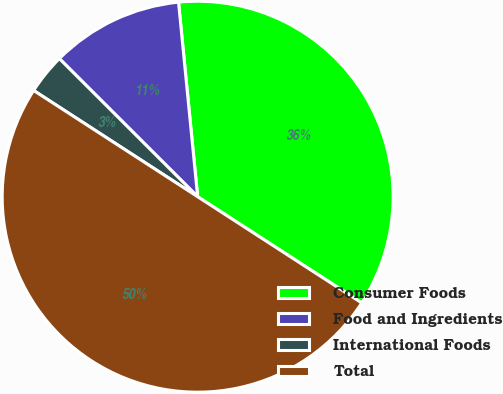Convert chart to OTSL. <chart><loc_0><loc_0><loc_500><loc_500><pie_chart><fcel>Consumer Foods<fcel>Food and Ingredients<fcel>International Foods<fcel>Total<nl><fcel>35.7%<fcel>10.95%<fcel>3.34%<fcel>50.0%<nl></chart> 